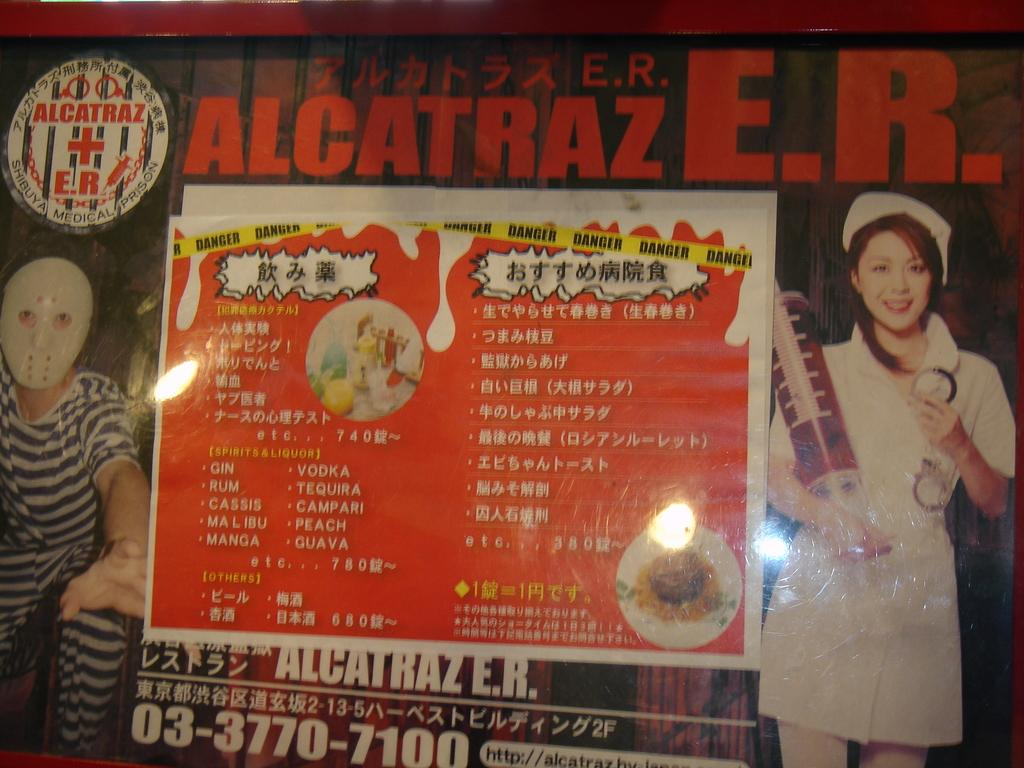What type of visual is the image in question? The image is a poster. What can be seen on the poster? There are images of people on the poster. Are there any words or phrases on the poster? Yes, there is text on the poster. What type of religious ceremony is depicted in the image? There is no religious ceremony depicted in the image; it features images of people and text on a poster. Can you see a girl playing on a hill in the image? There is no girl or hill present in the image; it is a poster with images of people and text. 